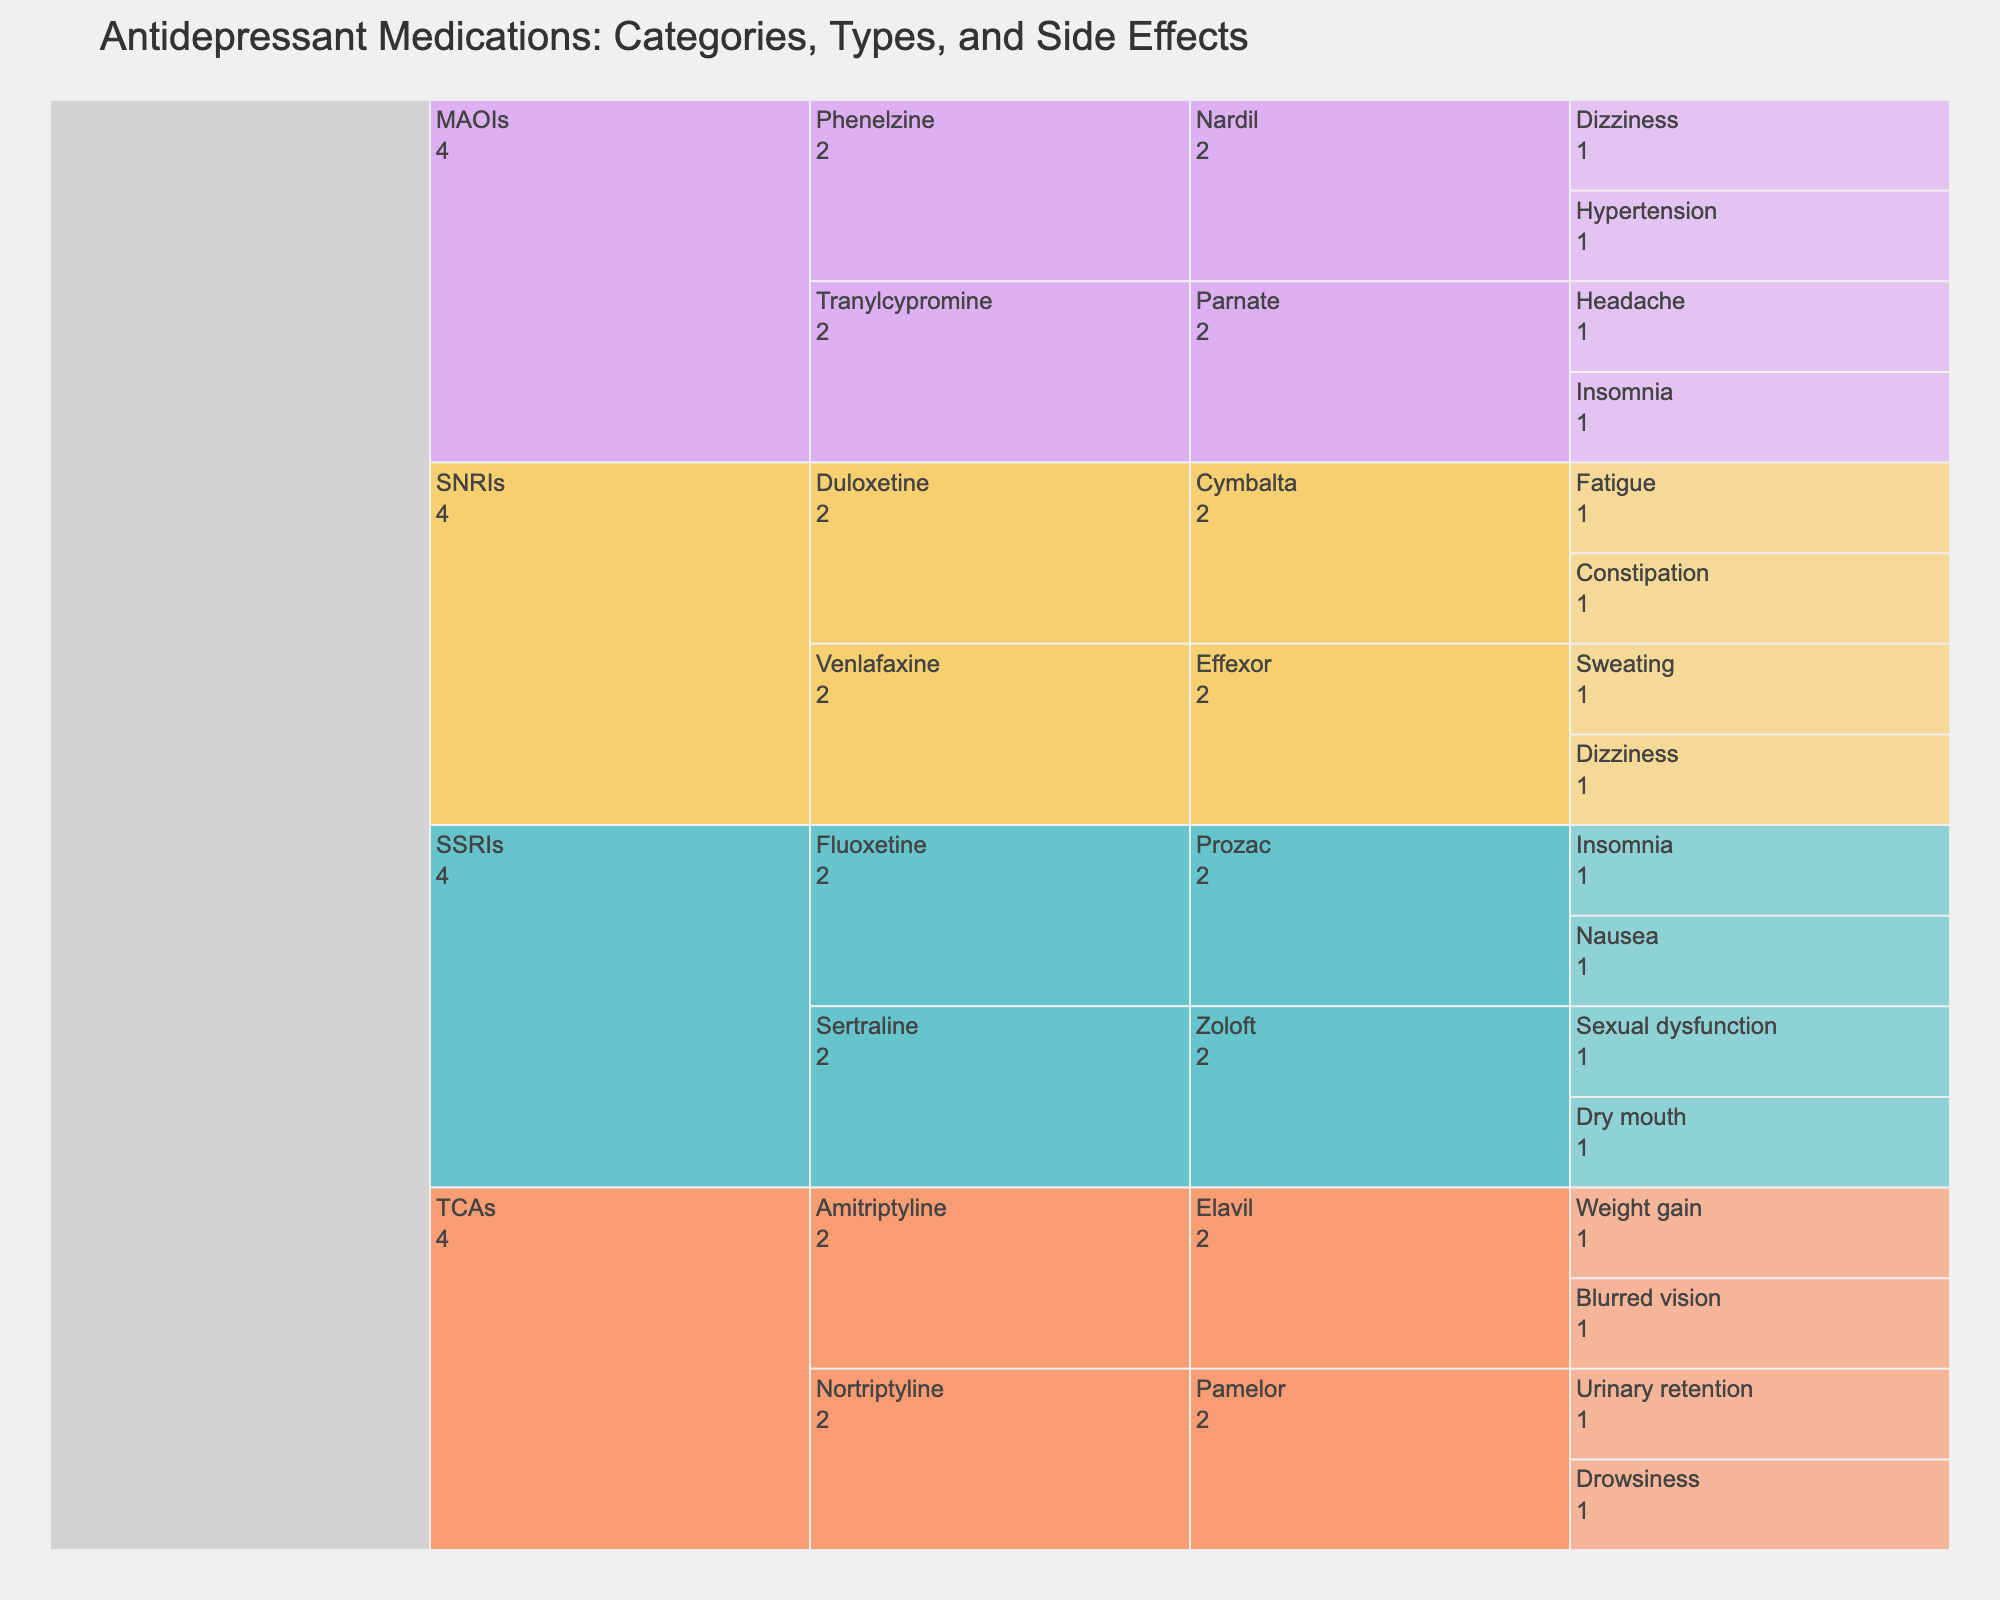Which category has the highest number of medications listed? To answer this, look at the top level categories in the icicle chart and count the number of unique medications listed under each category. SSRIs have two medications (Fluoxetine, Sertraline), SNRIs have two medications (Venlafaxine, Duloxetine), TCAs have two medications (Amitriptyline, Nortriptyline), MAOIs have two medications (Phenelzine, Tranylcypromine). All categories have the same number of medications.
Answer: All categories have the same number of medications Under which medication do we observe 'Fatigue' as a side effect? To find this, look for 'Fatigue' in the lowest level of the chart and trace upward to identify its associated medication. 'Fatigue' is listed under Duloxetine (SNRI).
Answer: Duloxetine (Cymbalta) What is the total number of side effects listed under the 'TCAs' category? Look at each subcategory within TCAs and count all the side effects under them. Amitriptyline (Elavil) has two side effects, Nortriptyline (Pamelor) has two side effects, leading to a sum of 2 + 2.
Answer: 4 Are there any medications that have 'Insomnia' as a side effect across different categories? Check each subcategory for the side effect 'Insomnia'. Fluoxetine (Prozac) in the SSRIs category and Tranylcypromine (Parnate) in the MAOIs category both list 'Insomnia' as a side effect.
Answer: Yes How many different side effects are associated with 'SSRIs'? Identify all unique side effects listed under the SSRIs category across all subcategories and sum them up. SSRIs have 'Nausea', 'Insomnia', 'Dry mouth', and 'Sexual dysfunction' through their medications Fluoxetine (Prozac) and Sertraline (Zoloft).
Answer: 4 Which side effect appears most frequently across all categories? Count how many times each side effect is listed across all categories and compare the counts. 'Insomnia' appears twice, once under Fluoxetine (Prozac) and once under Tranylcypromine (Parnate). No other side effect appears more than once.
Answer: Insomnia Compare the number of side effects between 'Venlafaxine' and 'Phenelzine'. Which one has more? Look at the side effects listed under each medication. Venlafaxine (Effexor) has 'Sweating' and 'Dizziness' (2 side effects), while Phenelzine (Nardil) has 'Dizziness' and 'Hypertension' (2 side effects). Both have the same number of side effects.
Answer: Equal number Which category's medications share the side effect 'Dizziness'? Locate 'Dizziness' in the chart and trace it up to the corresponding categories. 'Dizziness' is associated with Venlafaxine (Effexor) under SNRIs and Phenelzine (Nardil) under MAOIs.
Answer: SNRIs and MAOIs Which category has the widest variety of side effects? Count the distinct side effects listed under each category and compare the counts. SSRIs have 'Nausea', 'Insomnia', 'Dry mouth', 'Sexual dysfunction' (4). SNRIs have 'Sweating', 'Dizziness', 'Fatigue', 'Constipation' (4). TCAs have 'Weight gain', 'Blurred vision', 'Drowsiness', 'Urinary retention' (4). MAOIs have 'Dizziness', 'Hypertension', 'Insomnia', 'Headache' (4). Each category has the same variety of side effects.
Answer: Same variety in all categories 